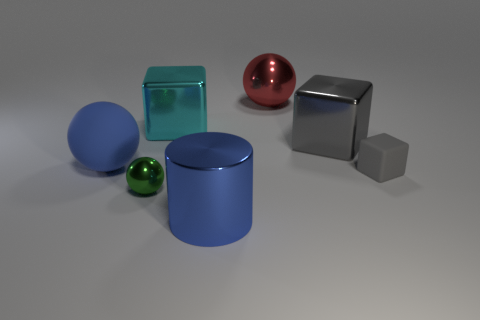Do the ball to the left of the tiny green metal ball and the large object that is in front of the large blue rubber thing have the same color?
Make the answer very short. Yes. There is a big object that is the same color as the small rubber block; what shape is it?
Provide a short and direct response. Cube. There is a sphere that is in front of the large gray shiny object and on the right side of the big blue ball; what size is it?
Your answer should be compact. Small. How many objects are there?
Give a very brief answer. 7. What number of blocks are rubber objects or green shiny objects?
Keep it short and to the point. 1. What number of big spheres are in front of the big cube to the left of the large ball that is right of the tiny green metallic ball?
Give a very brief answer. 1. What is the color of the other shiny sphere that is the same size as the blue sphere?
Ensure brevity in your answer.  Red. How many other objects are the same color as the cylinder?
Your answer should be very brief. 1. Are there more metallic things that are on the right side of the red metal sphere than small red metallic cylinders?
Offer a very short reply. Yes. Does the big blue cylinder have the same material as the tiny green sphere?
Offer a very short reply. Yes. 